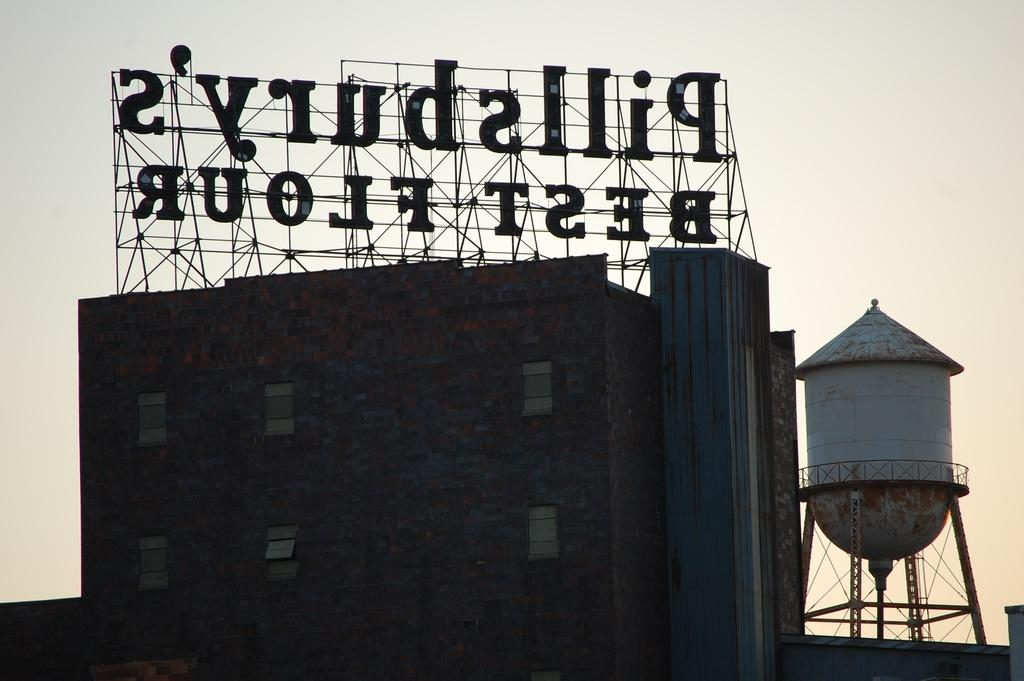What is the main object in the image? There is a name board in the image. Where is the name board located? The name board is on top of a building. What else can be seen on the right side of the image? There is a storage tank on the right side of the image. What is visible in the background of the image? The sky is visible in the background of the image. What type of voice can be heard coming from the name board in the image? There is no voice coming from the name board in the image, as it is a stationary object. 